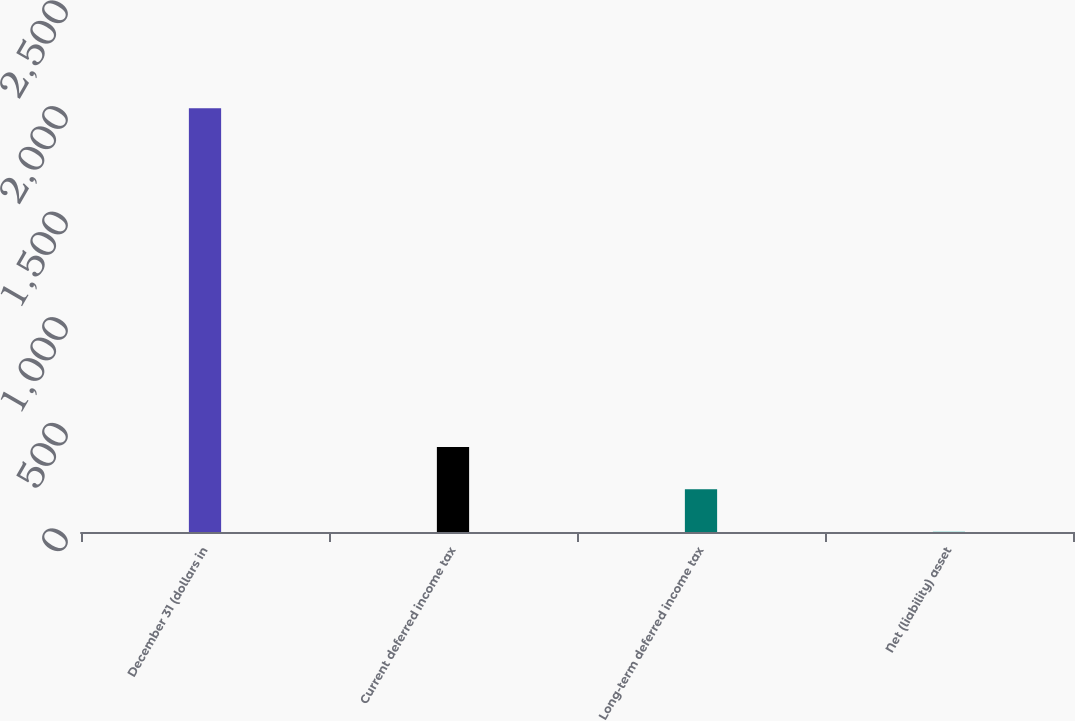Convert chart. <chart><loc_0><loc_0><loc_500><loc_500><bar_chart><fcel>December 31 (dollars in<fcel>Current deferred income tax<fcel>Long-term deferred income tax<fcel>Net (liability) asset<nl><fcel>2006<fcel>402.56<fcel>202.13<fcel>1.7<nl></chart> 